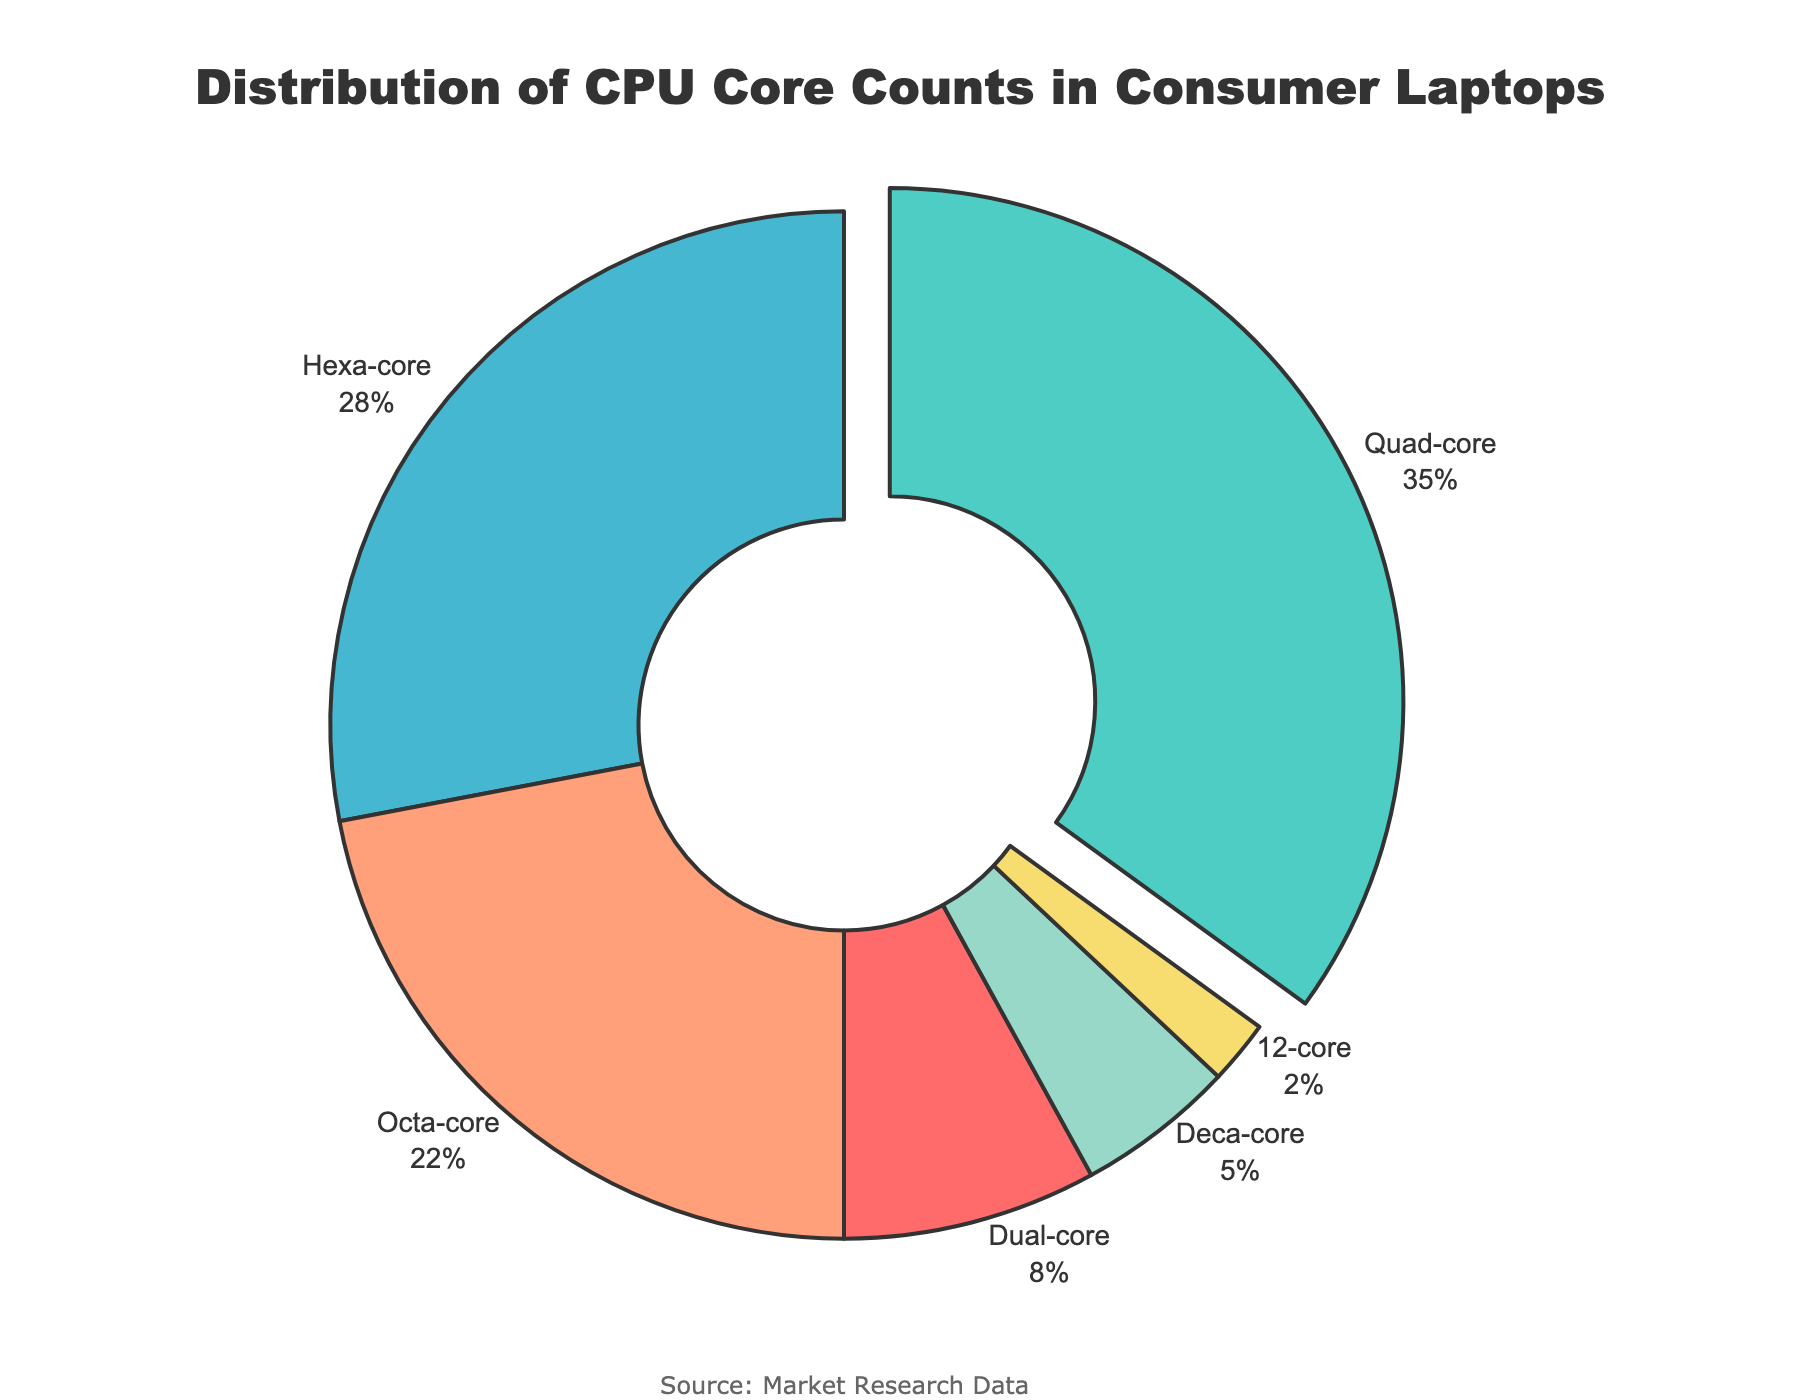What is the most common CPU core count in consumer laptops? The figure clearly highlights the Quad-core segment being pulled out from the pie chart and has the largest percentage.
Answer: Quad-core Which CPU core count is the least common? The segment with the smallest percentage slice labeled "12-core" is visually identifiable, representing only 2%.
Answer: 12-core What percentage of consumer laptops have more than 4 cores? Sum the percentages of Hexa-core, Octa-core, Deca-core, and 12-core. This is 28% + 22% + 5% + 2%.
Answer: 57% How much larger is the percentage of quad-core laptops compared to dual-core laptops? Subtract the percentage of dual-core laptops from the percentage of quad-core laptops, i.e., 35% - 8%.
Answer: 27% Which CPU core counts combined make up the majority of the market? Quad-core and Hexa-core segments combined already total 35% + 28% = 63%, exceeding 50%.
Answer: Quad-core and Hexa-core What colors represent the hexa-core and octa-core segments? Visually identify the colored segments for Hexa-core (marked by a specific slice) and Octa-core as #45B7D1 (Hexa-core) and #FFA07A (Octa-core).
Answer: Hexa-core: light blue, Octa-core: light coral What is the combined percentage of laptops with 8 or fewer cores? Sum the percentages of Dual-core, Quad-core, Hexa-core, and Octa-core sections. This is 8% + 35% + 28% + 22%.
Answer: 93% What is the difference in percentage points between consumer laptops with Deca-core and those with 12-core processors? Subtract the percentage of 12-core from Deca-core, i.e., 5% - 2%.
Answer: 3% If another segment represented laptops with 14 cores and it accounted for another 2%, what would be the new total percentage for laptops with more than 4 cores? Add 2% to the previous total for more than 4 cores (57%). This results in 57% + 2%.
Answer: 59% Are there more laptops with Quad-core processors than the combined total with Deca-core and 12-core processors? Compare the percentage of Quad-core (35%) to the sum of Deca-core and 12-core (5% + 2% = 7%). Since 35% is larger than 7%, the answer is yes.
Answer: Yes 